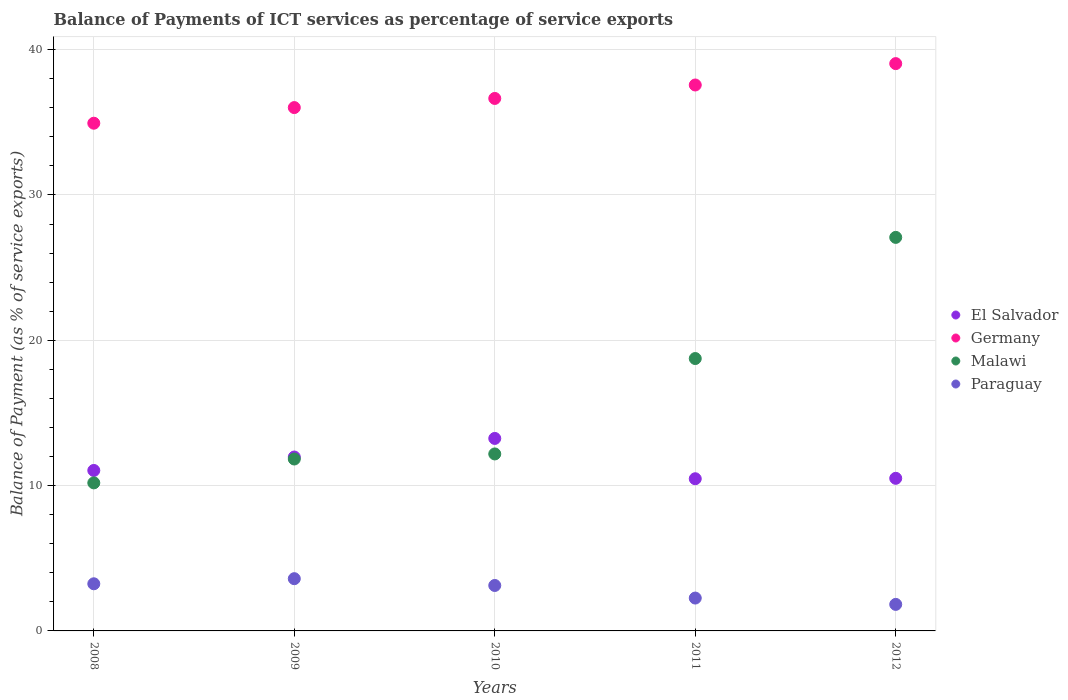Is the number of dotlines equal to the number of legend labels?
Ensure brevity in your answer.  Yes. What is the balance of payments of ICT services in Malawi in 2011?
Give a very brief answer. 18.75. Across all years, what is the maximum balance of payments of ICT services in Germany?
Make the answer very short. 39.04. Across all years, what is the minimum balance of payments of ICT services in Malawi?
Make the answer very short. 10.19. In which year was the balance of payments of ICT services in El Salvador maximum?
Give a very brief answer. 2010. What is the total balance of payments of ICT services in Paraguay in the graph?
Offer a very short reply. 14.05. What is the difference between the balance of payments of ICT services in El Salvador in 2011 and that in 2012?
Keep it short and to the point. -0.03. What is the difference between the balance of payments of ICT services in Paraguay in 2012 and the balance of payments of ICT services in Germany in 2010?
Your answer should be compact. -34.82. What is the average balance of payments of ICT services in Malawi per year?
Your answer should be very brief. 16. In the year 2009, what is the difference between the balance of payments of ICT services in El Salvador and balance of payments of ICT services in Germany?
Your answer should be compact. -24.05. What is the ratio of the balance of payments of ICT services in El Salvador in 2010 to that in 2012?
Your response must be concise. 1.26. What is the difference between the highest and the second highest balance of payments of ICT services in El Salvador?
Give a very brief answer. 1.28. What is the difference between the highest and the lowest balance of payments of ICT services in Paraguay?
Provide a short and direct response. 1.77. Is it the case that in every year, the sum of the balance of payments of ICT services in Paraguay and balance of payments of ICT services in Germany  is greater than the sum of balance of payments of ICT services in El Salvador and balance of payments of ICT services in Malawi?
Ensure brevity in your answer.  No. Is the balance of payments of ICT services in Germany strictly less than the balance of payments of ICT services in El Salvador over the years?
Your answer should be compact. No. What is the difference between two consecutive major ticks on the Y-axis?
Offer a terse response. 10. Are the values on the major ticks of Y-axis written in scientific E-notation?
Give a very brief answer. No. Does the graph contain any zero values?
Your answer should be compact. No. What is the title of the graph?
Your answer should be very brief. Balance of Payments of ICT services as percentage of service exports. What is the label or title of the Y-axis?
Keep it short and to the point. Balance of Payment (as % of service exports). What is the Balance of Payment (as % of service exports) in El Salvador in 2008?
Offer a terse response. 11.04. What is the Balance of Payment (as % of service exports) in Germany in 2008?
Provide a succinct answer. 34.94. What is the Balance of Payment (as % of service exports) in Malawi in 2008?
Make the answer very short. 10.19. What is the Balance of Payment (as % of service exports) in Paraguay in 2008?
Keep it short and to the point. 3.24. What is the Balance of Payment (as % of service exports) of El Salvador in 2009?
Give a very brief answer. 11.97. What is the Balance of Payment (as % of service exports) in Germany in 2009?
Give a very brief answer. 36.02. What is the Balance of Payment (as % of service exports) in Malawi in 2009?
Provide a short and direct response. 11.83. What is the Balance of Payment (as % of service exports) in Paraguay in 2009?
Ensure brevity in your answer.  3.59. What is the Balance of Payment (as % of service exports) in El Salvador in 2010?
Your response must be concise. 13.25. What is the Balance of Payment (as % of service exports) of Germany in 2010?
Give a very brief answer. 36.64. What is the Balance of Payment (as % of service exports) of Malawi in 2010?
Your answer should be compact. 12.18. What is the Balance of Payment (as % of service exports) in Paraguay in 2010?
Your answer should be compact. 3.13. What is the Balance of Payment (as % of service exports) in El Salvador in 2011?
Provide a succinct answer. 10.47. What is the Balance of Payment (as % of service exports) of Germany in 2011?
Provide a succinct answer. 37.57. What is the Balance of Payment (as % of service exports) of Malawi in 2011?
Keep it short and to the point. 18.75. What is the Balance of Payment (as % of service exports) of Paraguay in 2011?
Give a very brief answer. 2.26. What is the Balance of Payment (as % of service exports) of El Salvador in 2012?
Provide a succinct answer. 10.5. What is the Balance of Payment (as % of service exports) in Germany in 2012?
Give a very brief answer. 39.04. What is the Balance of Payment (as % of service exports) in Malawi in 2012?
Provide a short and direct response. 27.08. What is the Balance of Payment (as % of service exports) of Paraguay in 2012?
Make the answer very short. 1.83. Across all years, what is the maximum Balance of Payment (as % of service exports) of El Salvador?
Give a very brief answer. 13.25. Across all years, what is the maximum Balance of Payment (as % of service exports) of Germany?
Provide a succinct answer. 39.04. Across all years, what is the maximum Balance of Payment (as % of service exports) of Malawi?
Offer a terse response. 27.08. Across all years, what is the maximum Balance of Payment (as % of service exports) in Paraguay?
Provide a short and direct response. 3.59. Across all years, what is the minimum Balance of Payment (as % of service exports) in El Salvador?
Ensure brevity in your answer.  10.47. Across all years, what is the minimum Balance of Payment (as % of service exports) in Germany?
Your response must be concise. 34.94. Across all years, what is the minimum Balance of Payment (as % of service exports) in Malawi?
Provide a succinct answer. 10.19. Across all years, what is the minimum Balance of Payment (as % of service exports) of Paraguay?
Give a very brief answer. 1.83. What is the total Balance of Payment (as % of service exports) of El Salvador in the graph?
Ensure brevity in your answer.  57.23. What is the total Balance of Payment (as % of service exports) in Germany in the graph?
Your answer should be very brief. 184.21. What is the total Balance of Payment (as % of service exports) in Malawi in the graph?
Offer a very short reply. 80.02. What is the total Balance of Payment (as % of service exports) in Paraguay in the graph?
Your answer should be compact. 14.05. What is the difference between the Balance of Payment (as % of service exports) in El Salvador in 2008 and that in 2009?
Make the answer very short. -0.92. What is the difference between the Balance of Payment (as % of service exports) in Germany in 2008 and that in 2009?
Keep it short and to the point. -1.08. What is the difference between the Balance of Payment (as % of service exports) of Malawi in 2008 and that in 2009?
Your answer should be very brief. -1.64. What is the difference between the Balance of Payment (as % of service exports) in Paraguay in 2008 and that in 2009?
Make the answer very short. -0.35. What is the difference between the Balance of Payment (as % of service exports) of El Salvador in 2008 and that in 2010?
Your response must be concise. -2.2. What is the difference between the Balance of Payment (as % of service exports) in Germany in 2008 and that in 2010?
Keep it short and to the point. -1.7. What is the difference between the Balance of Payment (as % of service exports) in Malawi in 2008 and that in 2010?
Give a very brief answer. -1.99. What is the difference between the Balance of Payment (as % of service exports) of Paraguay in 2008 and that in 2010?
Offer a very short reply. 0.12. What is the difference between the Balance of Payment (as % of service exports) in El Salvador in 2008 and that in 2011?
Your response must be concise. 0.57. What is the difference between the Balance of Payment (as % of service exports) of Germany in 2008 and that in 2011?
Give a very brief answer. -2.63. What is the difference between the Balance of Payment (as % of service exports) in Malawi in 2008 and that in 2011?
Your answer should be compact. -8.56. What is the difference between the Balance of Payment (as % of service exports) in Paraguay in 2008 and that in 2011?
Your answer should be compact. 0.98. What is the difference between the Balance of Payment (as % of service exports) of El Salvador in 2008 and that in 2012?
Your response must be concise. 0.54. What is the difference between the Balance of Payment (as % of service exports) in Germany in 2008 and that in 2012?
Ensure brevity in your answer.  -4.1. What is the difference between the Balance of Payment (as % of service exports) in Malawi in 2008 and that in 2012?
Ensure brevity in your answer.  -16.9. What is the difference between the Balance of Payment (as % of service exports) in Paraguay in 2008 and that in 2012?
Make the answer very short. 1.42. What is the difference between the Balance of Payment (as % of service exports) in El Salvador in 2009 and that in 2010?
Offer a very short reply. -1.28. What is the difference between the Balance of Payment (as % of service exports) in Germany in 2009 and that in 2010?
Keep it short and to the point. -0.63. What is the difference between the Balance of Payment (as % of service exports) in Malawi in 2009 and that in 2010?
Give a very brief answer. -0.35. What is the difference between the Balance of Payment (as % of service exports) in Paraguay in 2009 and that in 2010?
Offer a terse response. 0.47. What is the difference between the Balance of Payment (as % of service exports) in El Salvador in 2009 and that in 2011?
Your answer should be compact. 1.49. What is the difference between the Balance of Payment (as % of service exports) of Germany in 2009 and that in 2011?
Your response must be concise. -1.55. What is the difference between the Balance of Payment (as % of service exports) in Malawi in 2009 and that in 2011?
Ensure brevity in your answer.  -6.91. What is the difference between the Balance of Payment (as % of service exports) of Paraguay in 2009 and that in 2011?
Your response must be concise. 1.33. What is the difference between the Balance of Payment (as % of service exports) in El Salvador in 2009 and that in 2012?
Offer a very short reply. 1.47. What is the difference between the Balance of Payment (as % of service exports) in Germany in 2009 and that in 2012?
Your answer should be compact. -3.03. What is the difference between the Balance of Payment (as % of service exports) in Malawi in 2009 and that in 2012?
Your answer should be compact. -15.25. What is the difference between the Balance of Payment (as % of service exports) of Paraguay in 2009 and that in 2012?
Provide a succinct answer. 1.77. What is the difference between the Balance of Payment (as % of service exports) in El Salvador in 2010 and that in 2011?
Make the answer very short. 2.77. What is the difference between the Balance of Payment (as % of service exports) of Germany in 2010 and that in 2011?
Give a very brief answer. -0.93. What is the difference between the Balance of Payment (as % of service exports) in Malawi in 2010 and that in 2011?
Ensure brevity in your answer.  -6.57. What is the difference between the Balance of Payment (as % of service exports) of Paraguay in 2010 and that in 2011?
Offer a terse response. 0.87. What is the difference between the Balance of Payment (as % of service exports) in El Salvador in 2010 and that in 2012?
Your answer should be compact. 2.75. What is the difference between the Balance of Payment (as % of service exports) of Germany in 2010 and that in 2012?
Offer a terse response. -2.4. What is the difference between the Balance of Payment (as % of service exports) in Malawi in 2010 and that in 2012?
Make the answer very short. -14.9. What is the difference between the Balance of Payment (as % of service exports) in Paraguay in 2010 and that in 2012?
Your answer should be compact. 1.3. What is the difference between the Balance of Payment (as % of service exports) of El Salvador in 2011 and that in 2012?
Keep it short and to the point. -0.03. What is the difference between the Balance of Payment (as % of service exports) of Germany in 2011 and that in 2012?
Make the answer very short. -1.47. What is the difference between the Balance of Payment (as % of service exports) of Malawi in 2011 and that in 2012?
Offer a terse response. -8.34. What is the difference between the Balance of Payment (as % of service exports) in Paraguay in 2011 and that in 2012?
Your answer should be very brief. 0.44. What is the difference between the Balance of Payment (as % of service exports) of El Salvador in 2008 and the Balance of Payment (as % of service exports) of Germany in 2009?
Offer a terse response. -24.97. What is the difference between the Balance of Payment (as % of service exports) of El Salvador in 2008 and the Balance of Payment (as % of service exports) of Malawi in 2009?
Your response must be concise. -0.79. What is the difference between the Balance of Payment (as % of service exports) in El Salvador in 2008 and the Balance of Payment (as % of service exports) in Paraguay in 2009?
Keep it short and to the point. 7.45. What is the difference between the Balance of Payment (as % of service exports) in Germany in 2008 and the Balance of Payment (as % of service exports) in Malawi in 2009?
Your answer should be compact. 23.11. What is the difference between the Balance of Payment (as % of service exports) in Germany in 2008 and the Balance of Payment (as % of service exports) in Paraguay in 2009?
Ensure brevity in your answer.  31.34. What is the difference between the Balance of Payment (as % of service exports) in Malawi in 2008 and the Balance of Payment (as % of service exports) in Paraguay in 2009?
Give a very brief answer. 6.59. What is the difference between the Balance of Payment (as % of service exports) in El Salvador in 2008 and the Balance of Payment (as % of service exports) in Germany in 2010?
Give a very brief answer. -25.6. What is the difference between the Balance of Payment (as % of service exports) in El Salvador in 2008 and the Balance of Payment (as % of service exports) in Malawi in 2010?
Ensure brevity in your answer.  -1.14. What is the difference between the Balance of Payment (as % of service exports) of El Salvador in 2008 and the Balance of Payment (as % of service exports) of Paraguay in 2010?
Provide a succinct answer. 7.92. What is the difference between the Balance of Payment (as % of service exports) of Germany in 2008 and the Balance of Payment (as % of service exports) of Malawi in 2010?
Give a very brief answer. 22.76. What is the difference between the Balance of Payment (as % of service exports) of Germany in 2008 and the Balance of Payment (as % of service exports) of Paraguay in 2010?
Offer a terse response. 31.81. What is the difference between the Balance of Payment (as % of service exports) in Malawi in 2008 and the Balance of Payment (as % of service exports) in Paraguay in 2010?
Make the answer very short. 7.06. What is the difference between the Balance of Payment (as % of service exports) in El Salvador in 2008 and the Balance of Payment (as % of service exports) in Germany in 2011?
Give a very brief answer. -26.53. What is the difference between the Balance of Payment (as % of service exports) of El Salvador in 2008 and the Balance of Payment (as % of service exports) of Malawi in 2011?
Keep it short and to the point. -7.7. What is the difference between the Balance of Payment (as % of service exports) of El Salvador in 2008 and the Balance of Payment (as % of service exports) of Paraguay in 2011?
Give a very brief answer. 8.78. What is the difference between the Balance of Payment (as % of service exports) in Germany in 2008 and the Balance of Payment (as % of service exports) in Malawi in 2011?
Make the answer very short. 16.19. What is the difference between the Balance of Payment (as % of service exports) in Germany in 2008 and the Balance of Payment (as % of service exports) in Paraguay in 2011?
Your response must be concise. 32.68. What is the difference between the Balance of Payment (as % of service exports) of Malawi in 2008 and the Balance of Payment (as % of service exports) of Paraguay in 2011?
Your response must be concise. 7.93. What is the difference between the Balance of Payment (as % of service exports) of El Salvador in 2008 and the Balance of Payment (as % of service exports) of Germany in 2012?
Provide a succinct answer. -28. What is the difference between the Balance of Payment (as % of service exports) of El Salvador in 2008 and the Balance of Payment (as % of service exports) of Malawi in 2012?
Ensure brevity in your answer.  -16.04. What is the difference between the Balance of Payment (as % of service exports) of El Salvador in 2008 and the Balance of Payment (as % of service exports) of Paraguay in 2012?
Your answer should be compact. 9.22. What is the difference between the Balance of Payment (as % of service exports) in Germany in 2008 and the Balance of Payment (as % of service exports) in Malawi in 2012?
Offer a very short reply. 7.86. What is the difference between the Balance of Payment (as % of service exports) of Germany in 2008 and the Balance of Payment (as % of service exports) of Paraguay in 2012?
Offer a terse response. 33.11. What is the difference between the Balance of Payment (as % of service exports) in Malawi in 2008 and the Balance of Payment (as % of service exports) in Paraguay in 2012?
Ensure brevity in your answer.  8.36. What is the difference between the Balance of Payment (as % of service exports) of El Salvador in 2009 and the Balance of Payment (as % of service exports) of Germany in 2010?
Ensure brevity in your answer.  -24.68. What is the difference between the Balance of Payment (as % of service exports) of El Salvador in 2009 and the Balance of Payment (as % of service exports) of Malawi in 2010?
Ensure brevity in your answer.  -0.21. What is the difference between the Balance of Payment (as % of service exports) of El Salvador in 2009 and the Balance of Payment (as % of service exports) of Paraguay in 2010?
Make the answer very short. 8.84. What is the difference between the Balance of Payment (as % of service exports) in Germany in 2009 and the Balance of Payment (as % of service exports) in Malawi in 2010?
Make the answer very short. 23.84. What is the difference between the Balance of Payment (as % of service exports) of Germany in 2009 and the Balance of Payment (as % of service exports) of Paraguay in 2010?
Provide a succinct answer. 32.89. What is the difference between the Balance of Payment (as % of service exports) of Malawi in 2009 and the Balance of Payment (as % of service exports) of Paraguay in 2010?
Offer a terse response. 8.7. What is the difference between the Balance of Payment (as % of service exports) of El Salvador in 2009 and the Balance of Payment (as % of service exports) of Germany in 2011?
Provide a short and direct response. -25.6. What is the difference between the Balance of Payment (as % of service exports) in El Salvador in 2009 and the Balance of Payment (as % of service exports) in Malawi in 2011?
Offer a very short reply. -6.78. What is the difference between the Balance of Payment (as % of service exports) in El Salvador in 2009 and the Balance of Payment (as % of service exports) in Paraguay in 2011?
Offer a terse response. 9.71. What is the difference between the Balance of Payment (as % of service exports) of Germany in 2009 and the Balance of Payment (as % of service exports) of Malawi in 2011?
Keep it short and to the point. 17.27. What is the difference between the Balance of Payment (as % of service exports) in Germany in 2009 and the Balance of Payment (as % of service exports) in Paraguay in 2011?
Offer a very short reply. 33.75. What is the difference between the Balance of Payment (as % of service exports) in Malawi in 2009 and the Balance of Payment (as % of service exports) in Paraguay in 2011?
Your answer should be very brief. 9.57. What is the difference between the Balance of Payment (as % of service exports) in El Salvador in 2009 and the Balance of Payment (as % of service exports) in Germany in 2012?
Provide a succinct answer. -27.07. What is the difference between the Balance of Payment (as % of service exports) of El Salvador in 2009 and the Balance of Payment (as % of service exports) of Malawi in 2012?
Offer a terse response. -15.12. What is the difference between the Balance of Payment (as % of service exports) of El Salvador in 2009 and the Balance of Payment (as % of service exports) of Paraguay in 2012?
Offer a terse response. 10.14. What is the difference between the Balance of Payment (as % of service exports) of Germany in 2009 and the Balance of Payment (as % of service exports) of Malawi in 2012?
Provide a succinct answer. 8.93. What is the difference between the Balance of Payment (as % of service exports) in Germany in 2009 and the Balance of Payment (as % of service exports) in Paraguay in 2012?
Provide a succinct answer. 34.19. What is the difference between the Balance of Payment (as % of service exports) in Malawi in 2009 and the Balance of Payment (as % of service exports) in Paraguay in 2012?
Ensure brevity in your answer.  10. What is the difference between the Balance of Payment (as % of service exports) in El Salvador in 2010 and the Balance of Payment (as % of service exports) in Germany in 2011?
Make the answer very short. -24.32. What is the difference between the Balance of Payment (as % of service exports) of El Salvador in 2010 and the Balance of Payment (as % of service exports) of Malawi in 2011?
Offer a terse response. -5.5. What is the difference between the Balance of Payment (as % of service exports) of El Salvador in 2010 and the Balance of Payment (as % of service exports) of Paraguay in 2011?
Offer a terse response. 10.99. What is the difference between the Balance of Payment (as % of service exports) of Germany in 2010 and the Balance of Payment (as % of service exports) of Malawi in 2011?
Make the answer very short. 17.9. What is the difference between the Balance of Payment (as % of service exports) in Germany in 2010 and the Balance of Payment (as % of service exports) in Paraguay in 2011?
Your answer should be very brief. 34.38. What is the difference between the Balance of Payment (as % of service exports) of Malawi in 2010 and the Balance of Payment (as % of service exports) of Paraguay in 2011?
Offer a very short reply. 9.92. What is the difference between the Balance of Payment (as % of service exports) of El Salvador in 2010 and the Balance of Payment (as % of service exports) of Germany in 2012?
Provide a succinct answer. -25.79. What is the difference between the Balance of Payment (as % of service exports) of El Salvador in 2010 and the Balance of Payment (as % of service exports) of Malawi in 2012?
Provide a succinct answer. -13.84. What is the difference between the Balance of Payment (as % of service exports) in El Salvador in 2010 and the Balance of Payment (as % of service exports) in Paraguay in 2012?
Ensure brevity in your answer.  11.42. What is the difference between the Balance of Payment (as % of service exports) in Germany in 2010 and the Balance of Payment (as % of service exports) in Malawi in 2012?
Provide a short and direct response. 9.56. What is the difference between the Balance of Payment (as % of service exports) of Germany in 2010 and the Balance of Payment (as % of service exports) of Paraguay in 2012?
Your answer should be compact. 34.82. What is the difference between the Balance of Payment (as % of service exports) in Malawi in 2010 and the Balance of Payment (as % of service exports) in Paraguay in 2012?
Ensure brevity in your answer.  10.35. What is the difference between the Balance of Payment (as % of service exports) of El Salvador in 2011 and the Balance of Payment (as % of service exports) of Germany in 2012?
Your answer should be very brief. -28.57. What is the difference between the Balance of Payment (as % of service exports) in El Salvador in 2011 and the Balance of Payment (as % of service exports) in Malawi in 2012?
Ensure brevity in your answer.  -16.61. What is the difference between the Balance of Payment (as % of service exports) in El Salvador in 2011 and the Balance of Payment (as % of service exports) in Paraguay in 2012?
Give a very brief answer. 8.65. What is the difference between the Balance of Payment (as % of service exports) of Germany in 2011 and the Balance of Payment (as % of service exports) of Malawi in 2012?
Make the answer very short. 10.49. What is the difference between the Balance of Payment (as % of service exports) of Germany in 2011 and the Balance of Payment (as % of service exports) of Paraguay in 2012?
Provide a short and direct response. 35.74. What is the difference between the Balance of Payment (as % of service exports) in Malawi in 2011 and the Balance of Payment (as % of service exports) in Paraguay in 2012?
Keep it short and to the point. 16.92. What is the average Balance of Payment (as % of service exports) in El Salvador per year?
Your response must be concise. 11.45. What is the average Balance of Payment (as % of service exports) of Germany per year?
Provide a short and direct response. 36.84. What is the average Balance of Payment (as % of service exports) of Malawi per year?
Offer a very short reply. 16. What is the average Balance of Payment (as % of service exports) of Paraguay per year?
Keep it short and to the point. 2.81. In the year 2008, what is the difference between the Balance of Payment (as % of service exports) of El Salvador and Balance of Payment (as % of service exports) of Germany?
Offer a very short reply. -23.9. In the year 2008, what is the difference between the Balance of Payment (as % of service exports) of El Salvador and Balance of Payment (as % of service exports) of Malawi?
Provide a succinct answer. 0.86. In the year 2008, what is the difference between the Balance of Payment (as % of service exports) in El Salvador and Balance of Payment (as % of service exports) in Paraguay?
Ensure brevity in your answer.  7.8. In the year 2008, what is the difference between the Balance of Payment (as % of service exports) of Germany and Balance of Payment (as % of service exports) of Malawi?
Make the answer very short. 24.75. In the year 2008, what is the difference between the Balance of Payment (as % of service exports) in Germany and Balance of Payment (as % of service exports) in Paraguay?
Ensure brevity in your answer.  31.7. In the year 2008, what is the difference between the Balance of Payment (as % of service exports) of Malawi and Balance of Payment (as % of service exports) of Paraguay?
Ensure brevity in your answer.  6.94. In the year 2009, what is the difference between the Balance of Payment (as % of service exports) of El Salvador and Balance of Payment (as % of service exports) of Germany?
Make the answer very short. -24.05. In the year 2009, what is the difference between the Balance of Payment (as % of service exports) of El Salvador and Balance of Payment (as % of service exports) of Malawi?
Make the answer very short. 0.14. In the year 2009, what is the difference between the Balance of Payment (as % of service exports) of El Salvador and Balance of Payment (as % of service exports) of Paraguay?
Your response must be concise. 8.37. In the year 2009, what is the difference between the Balance of Payment (as % of service exports) in Germany and Balance of Payment (as % of service exports) in Malawi?
Give a very brief answer. 24.18. In the year 2009, what is the difference between the Balance of Payment (as % of service exports) of Germany and Balance of Payment (as % of service exports) of Paraguay?
Your answer should be compact. 32.42. In the year 2009, what is the difference between the Balance of Payment (as % of service exports) of Malawi and Balance of Payment (as % of service exports) of Paraguay?
Offer a very short reply. 8.24. In the year 2010, what is the difference between the Balance of Payment (as % of service exports) in El Salvador and Balance of Payment (as % of service exports) in Germany?
Your answer should be very brief. -23.4. In the year 2010, what is the difference between the Balance of Payment (as % of service exports) of El Salvador and Balance of Payment (as % of service exports) of Malawi?
Provide a succinct answer. 1.07. In the year 2010, what is the difference between the Balance of Payment (as % of service exports) of El Salvador and Balance of Payment (as % of service exports) of Paraguay?
Your answer should be compact. 10.12. In the year 2010, what is the difference between the Balance of Payment (as % of service exports) of Germany and Balance of Payment (as % of service exports) of Malawi?
Your answer should be compact. 24.46. In the year 2010, what is the difference between the Balance of Payment (as % of service exports) in Germany and Balance of Payment (as % of service exports) in Paraguay?
Give a very brief answer. 33.52. In the year 2010, what is the difference between the Balance of Payment (as % of service exports) of Malawi and Balance of Payment (as % of service exports) of Paraguay?
Make the answer very short. 9.05. In the year 2011, what is the difference between the Balance of Payment (as % of service exports) of El Salvador and Balance of Payment (as % of service exports) of Germany?
Your answer should be very brief. -27.1. In the year 2011, what is the difference between the Balance of Payment (as % of service exports) of El Salvador and Balance of Payment (as % of service exports) of Malawi?
Your response must be concise. -8.27. In the year 2011, what is the difference between the Balance of Payment (as % of service exports) in El Salvador and Balance of Payment (as % of service exports) in Paraguay?
Make the answer very short. 8.21. In the year 2011, what is the difference between the Balance of Payment (as % of service exports) of Germany and Balance of Payment (as % of service exports) of Malawi?
Your response must be concise. 18.82. In the year 2011, what is the difference between the Balance of Payment (as % of service exports) in Germany and Balance of Payment (as % of service exports) in Paraguay?
Make the answer very short. 35.31. In the year 2011, what is the difference between the Balance of Payment (as % of service exports) in Malawi and Balance of Payment (as % of service exports) in Paraguay?
Offer a terse response. 16.48. In the year 2012, what is the difference between the Balance of Payment (as % of service exports) in El Salvador and Balance of Payment (as % of service exports) in Germany?
Make the answer very short. -28.54. In the year 2012, what is the difference between the Balance of Payment (as % of service exports) of El Salvador and Balance of Payment (as % of service exports) of Malawi?
Make the answer very short. -16.58. In the year 2012, what is the difference between the Balance of Payment (as % of service exports) in El Salvador and Balance of Payment (as % of service exports) in Paraguay?
Your answer should be very brief. 8.68. In the year 2012, what is the difference between the Balance of Payment (as % of service exports) of Germany and Balance of Payment (as % of service exports) of Malawi?
Offer a very short reply. 11.96. In the year 2012, what is the difference between the Balance of Payment (as % of service exports) of Germany and Balance of Payment (as % of service exports) of Paraguay?
Provide a succinct answer. 37.22. In the year 2012, what is the difference between the Balance of Payment (as % of service exports) of Malawi and Balance of Payment (as % of service exports) of Paraguay?
Provide a succinct answer. 25.26. What is the ratio of the Balance of Payment (as % of service exports) in El Salvador in 2008 to that in 2009?
Ensure brevity in your answer.  0.92. What is the ratio of the Balance of Payment (as % of service exports) in Germany in 2008 to that in 2009?
Offer a very short reply. 0.97. What is the ratio of the Balance of Payment (as % of service exports) of Malawi in 2008 to that in 2009?
Your response must be concise. 0.86. What is the ratio of the Balance of Payment (as % of service exports) in Paraguay in 2008 to that in 2009?
Keep it short and to the point. 0.9. What is the ratio of the Balance of Payment (as % of service exports) in El Salvador in 2008 to that in 2010?
Offer a very short reply. 0.83. What is the ratio of the Balance of Payment (as % of service exports) in Germany in 2008 to that in 2010?
Make the answer very short. 0.95. What is the ratio of the Balance of Payment (as % of service exports) of Malawi in 2008 to that in 2010?
Your answer should be compact. 0.84. What is the ratio of the Balance of Payment (as % of service exports) in Paraguay in 2008 to that in 2010?
Offer a terse response. 1.04. What is the ratio of the Balance of Payment (as % of service exports) in El Salvador in 2008 to that in 2011?
Your response must be concise. 1.05. What is the ratio of the Balance of Payment (as % of service exports) in Malawi in 2008 to that in 2011?
Provide a short and direct response. 0.54. What is the ratio of the Balance of Payment (as % of service exports) in Paraguay in 2008 to that in 2011?
Offer a very short reply. 1.43. What is the ratio of the Balance of Payment (as % of service exports) in El Salvador in 2008 to that in 2012?
Ensure brevity in your answer.  1.05. What is the ratio of the Balance of Payment (as % of service exports) in Germany in 2008 to that in 2012?
Your answer should be very brief. 0.89. What is the ratio of the Balance of Payment (as % of service exports) in Malawi in 2008 to that in 2012?
Offer a very short reply. 0.38. What is the ratio of the Balance of Payment (as % of service exports) of Paraguay in 2008 to that in 2012?
Your answer should be very brief. 1.78. What is the ratio of the Balance of Payment (as % of service exports) in El Salvador in 2009 to that in 2010?
Offer a terse response. 0.9. What is the ratio of the Balance of Payment (as % of service exports) in Germany in 2009 to that in 2010?
Your answer should be compact. 0.98. What is the ratio of the Balance of Payment (as % of service exports) of Malawi in 2009 to that in 2010?
Offer a terse response. 0.97. What is the ratio of the Balance of Payment (as % of service exports) of Paraguay in 2009 to that in 2010?
Provide a short and direct response. 1.15. What is the ratio of the Balance of Payment (as % of service exports) in El Salvador in 2009 to that in 2011?
Offer a terse response. 1.14. What is the ratio of the Balance of Payment (as % of service exports) in Germany in 2009 to that in 2011?
Ensure brevity in your answer.  0.96. What is the ratio of the Balance of Payment (as % of service exports) of Malawi in 2009 to that in 2011?
Ensure brevity in your answer.  0.63. What is the ratio of the Balance of Payment (as % of service exports) of Paraguay in 2009 to that in 2011?
Ensure brevity in your answer.  1.59. What is the ratio of the Balance of Payment (as % of service exports) of El Salvador in 2009 to that in 2012?
Your response must be concise. 1.14. What is the ratio of the Balance of Payment (as % of service exports) of Germany in 2009 to that in 2012?
Your answer should be compact. 0.92. What is the ratio of the Balance of Payment (as % of service exports) in Malawi in 2009 to that in 2012?
Offer a very short reply. 0.44. What is the ratio of the Balance of Payment (as % of service exports) of Paraguay in 2009 to that in 2012?
Your response must be concise. 1.97. What is the ratio of the Balance of Payment (as % of service exports) in El Salvador in 2010 to that in 2011?
Ensure brevity in your answer.  1.26. What is the ratio of the Balance of Payment (as % of service exports) in Germany in 2010 to that in 2011?
Your response must be concise. 0.98. What is the ratio of the Balance of Payment (as % of service exports) of Malawi in 2010 to that in 2011?
Ensure brevity in your answer.  0.65. What is the ratio of the Balance of Payment (as % of service exports) of Paraguay in 2010 to that in 2011?
Your response must be concise. 1.38. What is the ratio of the Balance of Payment (as % of service exports) in El Salvador in 2010 to that in 2012?
Give a very brief answer. 1.26. What is the ratio of the Balance of Payment (as % of service exports) in Germany in 2010 to that in 2012?
Provide a succinct answer. 0.94. What is the ratio of the Balance of Payment (as % of service exports) in Malawi in 2010 to that in 2012?
Give a very brief answer. 0.45. What is the ratio of the Balance of Payment (as % of service exports) in Paraguay in 2010 to that in 2012?
Provide a short and direct response. 1.71. What is the ratio of the Balance of Payment (as % of service exports) of El Salvador in 2011 to that in 2012?
Give a very brief answer. 1. What is the ratio of the Balance of Payment (as % of service exports) in Germany in 2011 to that in 2012?
Provide a short and direct response. 0.96. What is the ratio of the Balance of Payment (as % of service exports) of Malawi in 2011 to that in 2012?
Ensure brevity in your answer.  0.69. What is the ratio of the Balance of Payment (as % of service exports) in Paraguay in 2011 to that in 2012?
Your response must be concise. 1.24. What is the difference between the highest and the second highest Balance of Payment (as % of service exports) of El Salvador?
Provide a short and direct response. 1.28. What is the difference between the highest and the second highest Balance of Payment (as % of service exports) in Germany?
Provide a succinct answer. 1.47. What is the difference between the highest and the second highest Balance of Payment (as % of service exports) in Malawi?
Your response must be concise. 8.34. What is the difference between the highest and the second highest Balance of Payment (as % of service exports) of Paraguay?
Ensure brevity in your answer.  0.35. What is the difference between the highest and the lowest Balance of Payment (as % of service exports) of El Salvador?
Offer a terse response. 2.77. What is the difference between the highest and the lowest Balance of Payment (as % of service exports) in Germany?
Your answer should be compact. 4.1. What is the difference between the highest and the lowest Balance of Payment (as % of service exports) in Malawi?
Your answer should be compact. 16.9. What is the difference between the highest and the lowest Balance of Payment (as % of service exports) in Paraguay?
Provide a succinct answer. 1.77. 